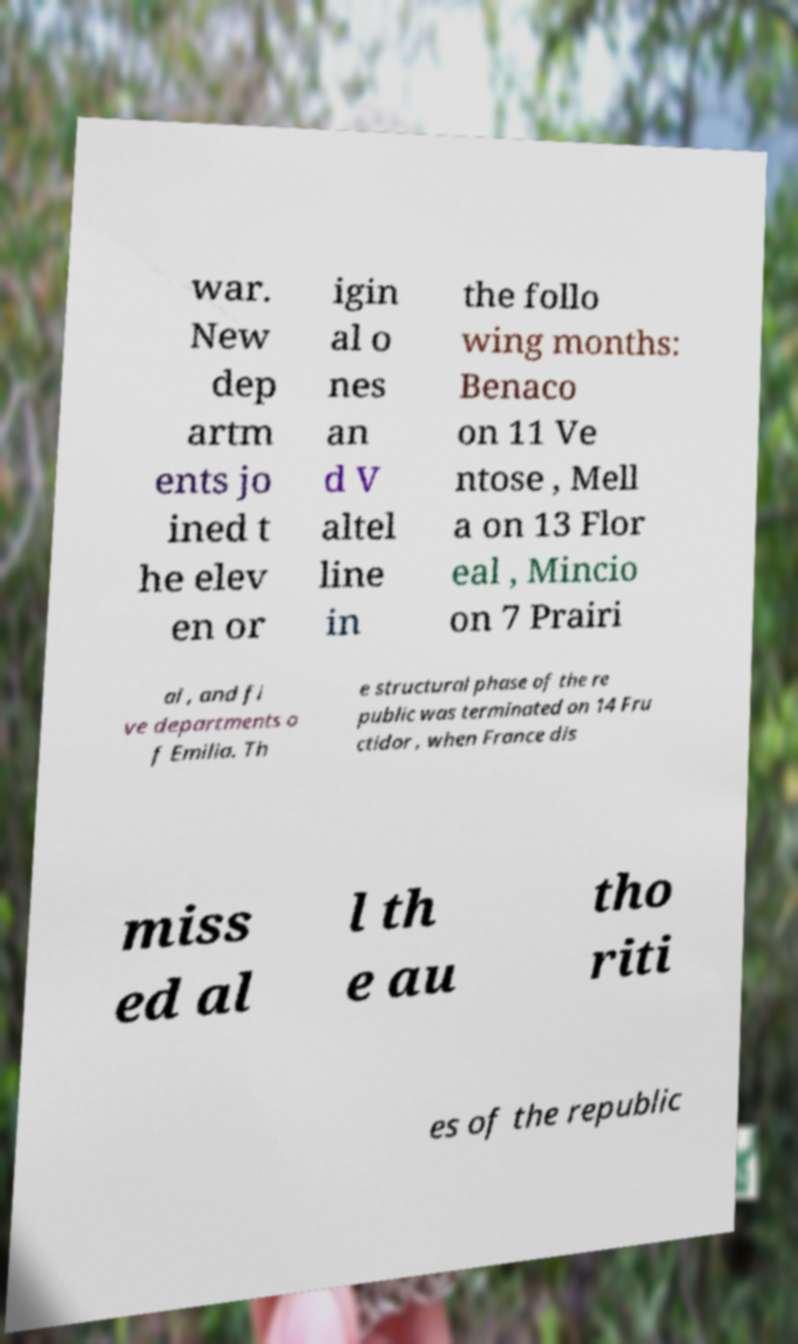Can you accurately transcribe the text from the provided image for me? war. New dep artm ents jo ined t he elev en or igin al o nes an d V altel line in the follo wing months: Benaco on 11 Ve ntose , Mell a on 13 Flor eal , Mincio on 7 Prairi al , and fi ve departments o f Emilia. Th e structural phase of the re public was terminated on 14 Fru ctidor , when France dis miss ed al l th e au tho riti es of the republic 